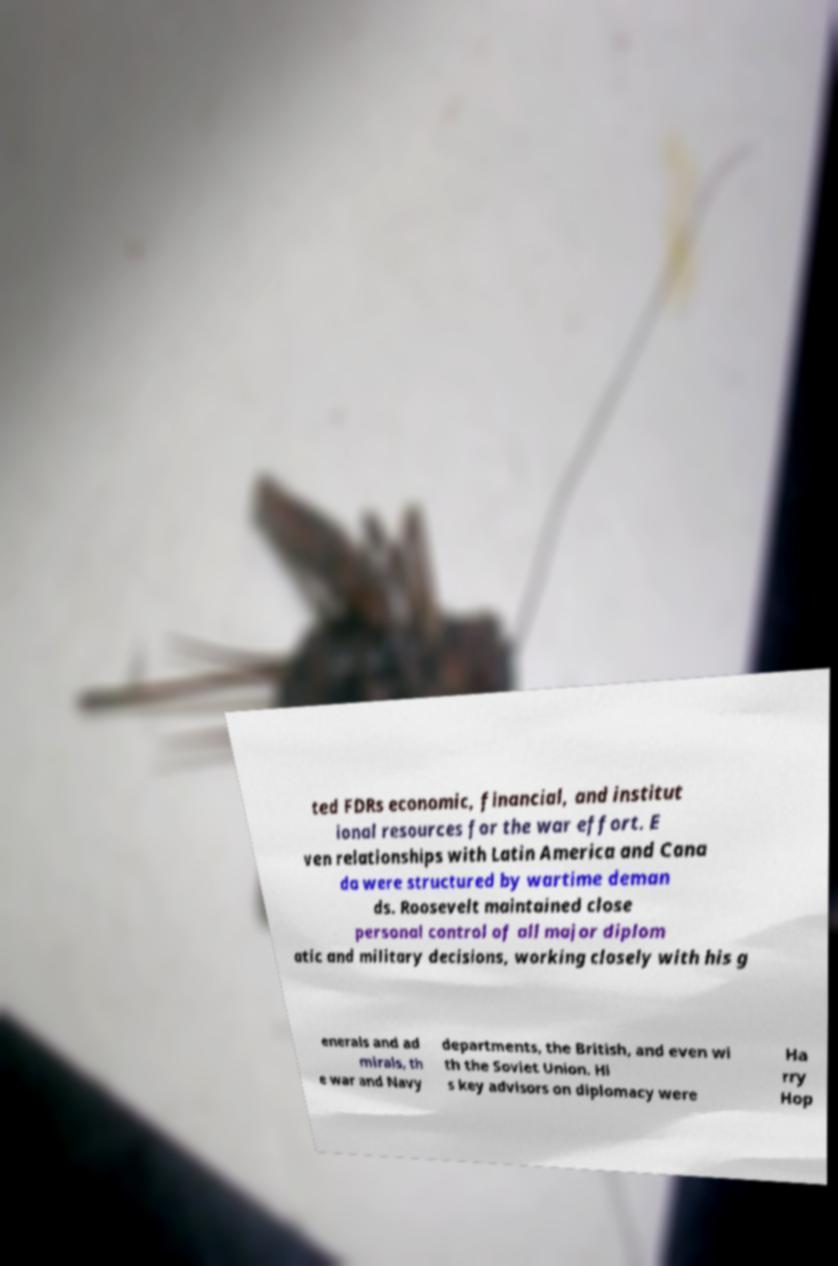Can you read and provide the text displayed in the image?This photo seems to have some interesting text. Can you extract and type it out for me? ted FDRs economic, financial, and institut ional resources for the war effort. E ven relationships with Latin America and Cana da were structured by wartime deman ds. Roosevelt maintained close personal control of all major diplom atic and military decisions, working closely with his g enerals and ad mirals, th e war and Navy departments, the British, and even wi th the Soviet Union. Hi s key advisors on diplomacy were Ha rry Hop 